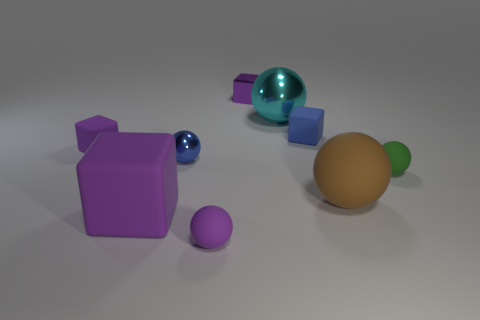There is a rubber object that is behind the small green matte thing and on the left side of the blue rubber thing; what size is it?
Offer a terse response. Small. Are there fewer purple rubber balls that are in front of the blue sphere than purple rubber things?
Provide a succinct answer. Yes. There is a big cyan object that is made of the same material as the blue sphere; what shape is it?
Make the answer very short. Sphere. Is the shape of the large object that is right of the large cyan metal object the same as the large matte object that is on the left side of the blue shiny sphere?
Make the answer very short. No. Are there fewer blocks left of the shiny cube than tiny blue metallic objects that are right of the brown ball?
Give a very brief answer. No. What shape is the small metallic object that is the same color as the big matte cube?
Offer a very short reply. Cube. What number of cyan metallic spheres have the same size as the blue matte block?
Give a very brief answer. 0. Do the small purple block that is on the right side of the big purple block and the purple ball have the same material?
Provide a succinct answer. No. Are any big blocks visible?
Your response must be concise. Yes. There is a brown sphere that is made of the same material as the green object; what is its size?
Provide a succinct answer. Large. 